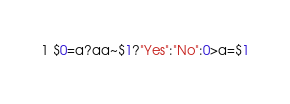<code> <loc_0><loc_0><loc_500><loc_500><_Awk_>$0=a?aa~$1?"Yes":"No":0>a=$1</code> 